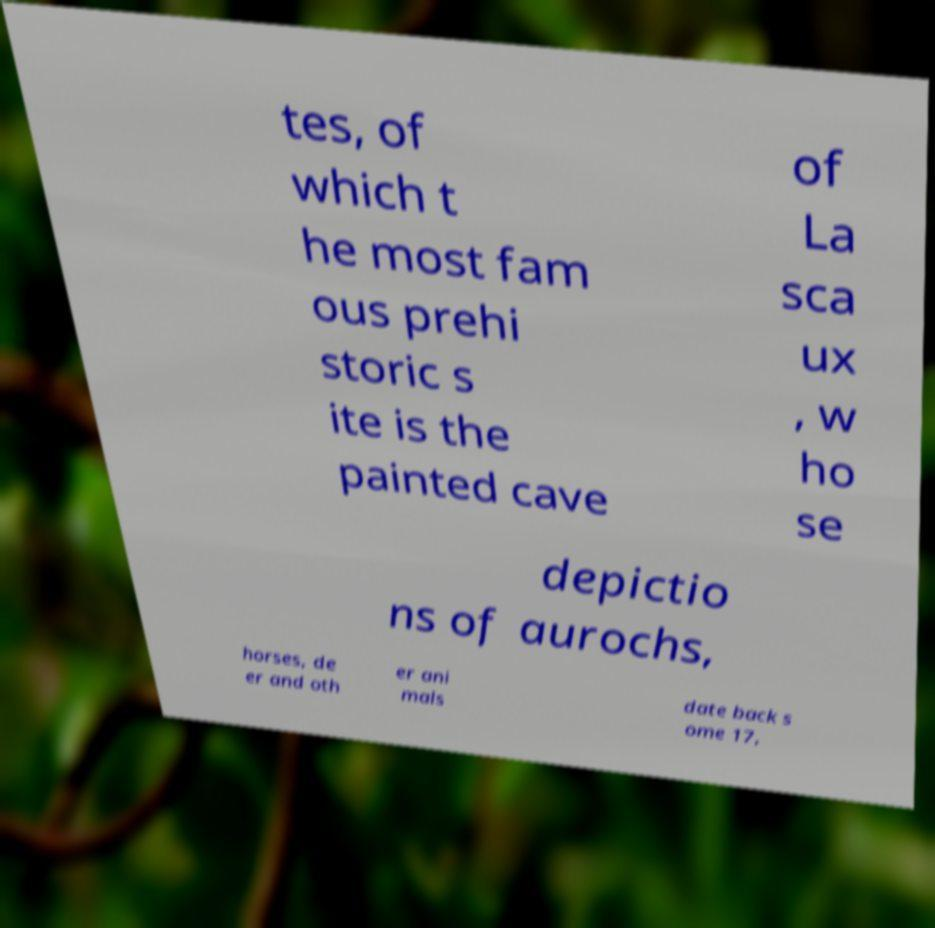I need the written content from this picture converted into text. Can you do that? tes, of which t he most fam ous prehi storic s ite is the painted cave of La sca ux , w ho se depictio ns of aurochs, horses, de er and oth er ani mals date back s ome 17, 